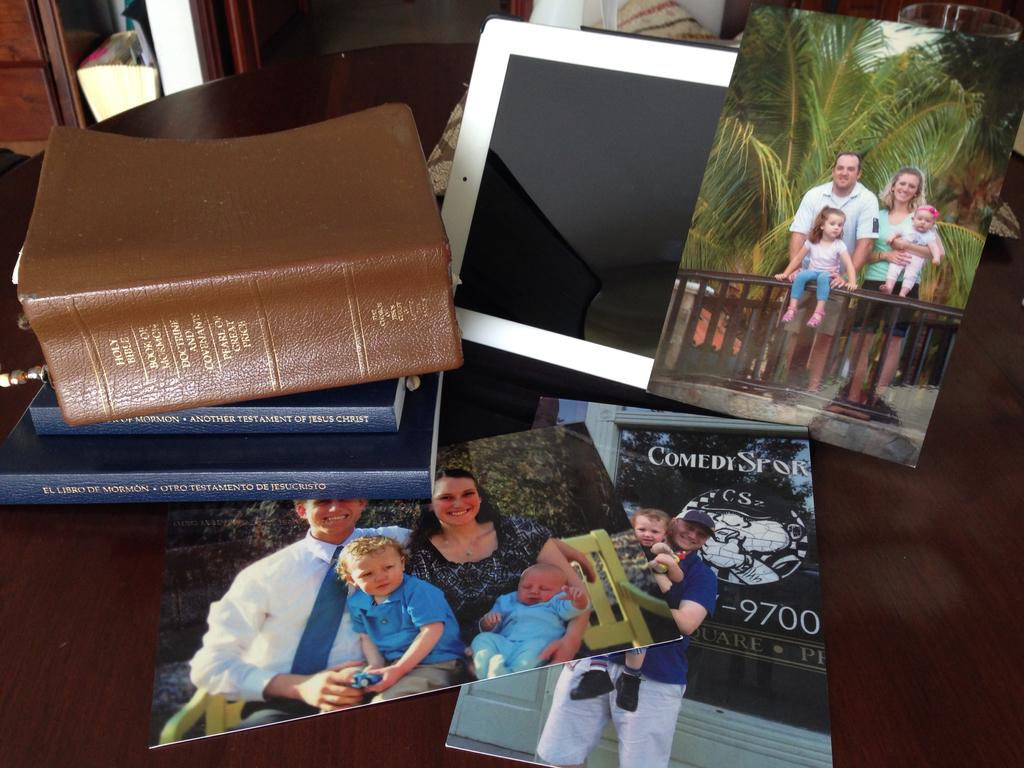What type of objects can be seen in the image? There are books and photographs of people in the image. Can you describe the photographs in the image? The photographs in the image depict people. What might the books be used for? The books might be used for reading or reference. What type of food is being prepared in the image? There is no food or preparation of food visible in the image. What type of branch can be seen in the image? There is no branch present in the image. 